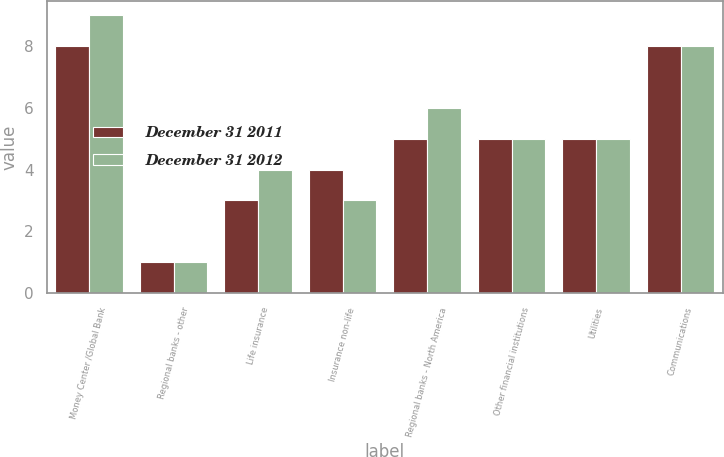<chart> <loc_0><loc_0><loc_500><loc_500><stacked_bar_chart><ecel><fcel>Money Center /Global Bank<fcel>Regional banks - other<fcel>Life insurance<fcel>Insurance non-life<fcel>Regional banks - North America<fcel>Other financial institutions<fcel>Utilities<fcel>Communications<nl><fcel>December 31 2011<fcel>8<fcel>1<fcel>3<fcel>4<fcel>5<fcel>5<fcel>5<fcel>8<nl><fcel>December 31 2012<fcel>9<fcel>1<fcel>4<fcel>3<fcel>6<fcel>5<fcel>5<fcel>8<nl></chart> 